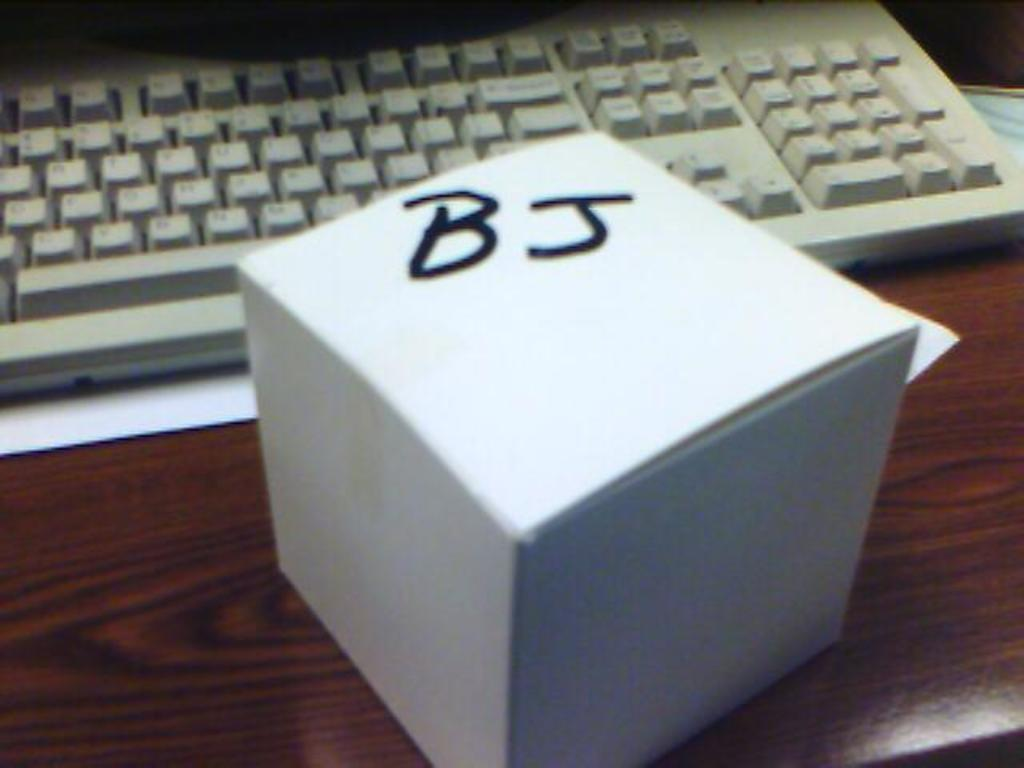<image>
Provide a brief description of the given image. A white box with the letters BJ written on it sitting on a desk. 